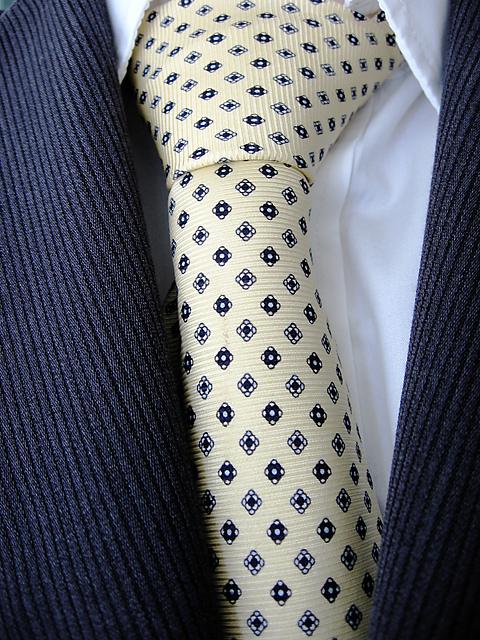What color is the man's shirt?
Keep it brief. White. Is the person wearing a coat?
Answer briefly. Yes. Does the tie match the jacket?
Short answer required. Yes. What pattern is on the man's tie?
Quick response, please. Diamonds. 